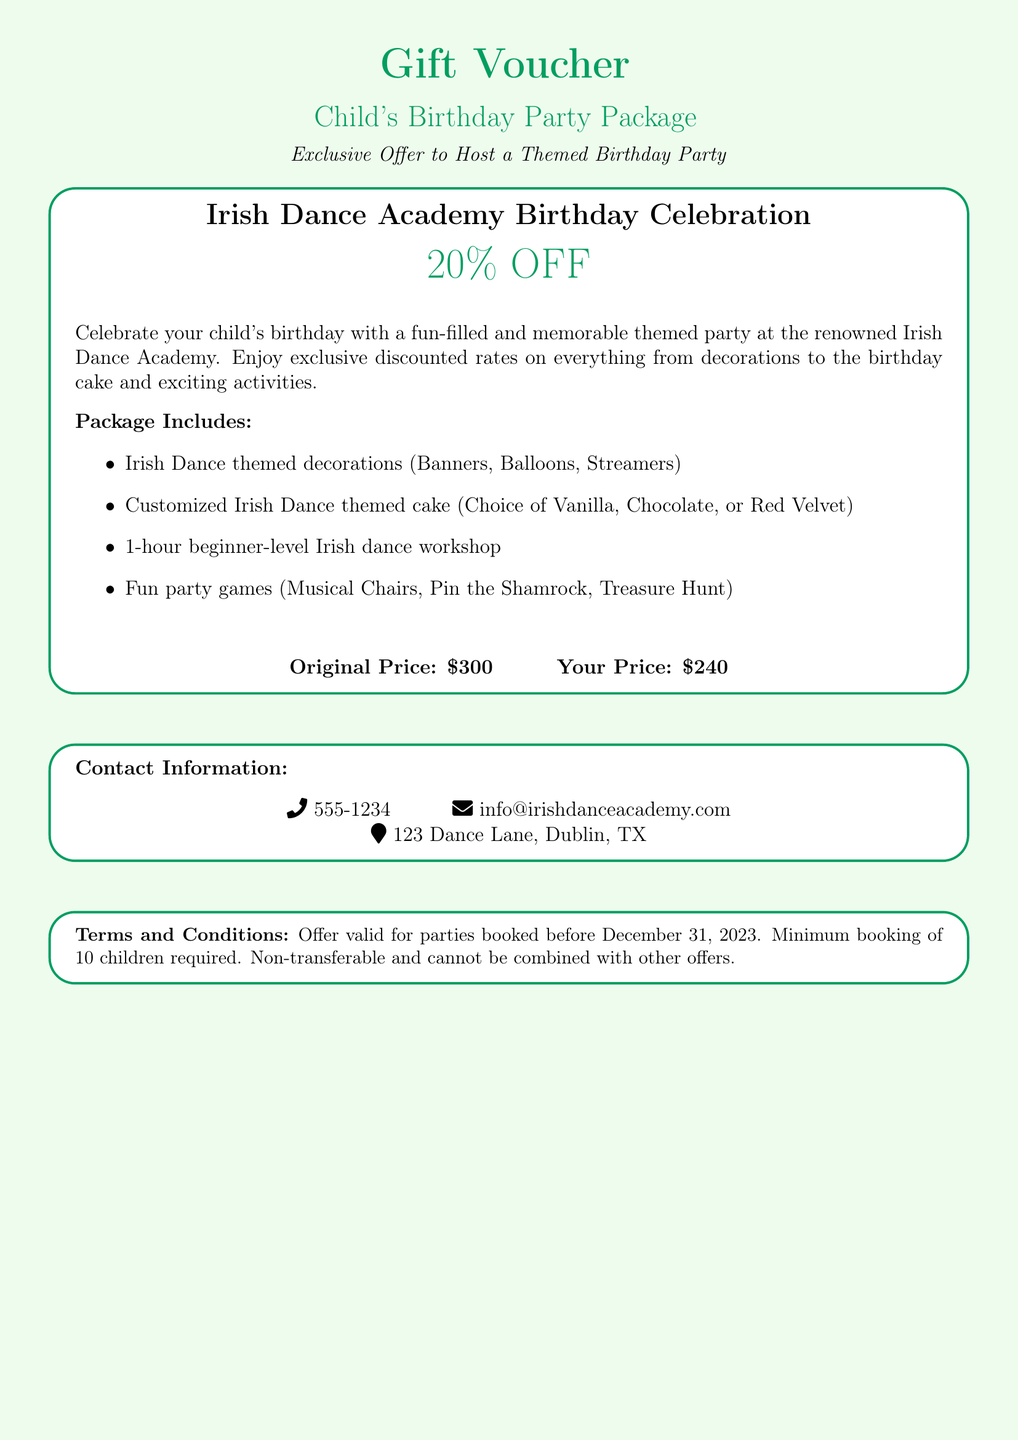what is the discount percentage for the birthday party package? The document states a discount of 20% off the original price for the birthday party package.
Answer: 20% OFF what is the original price of the birthday party package? The original price mentioned in the document for the birthday party package is $300.
Answer: $300 what is the discounted price of the birthday party package? The discounted price after the 20% off is clearly shown as $240 in the document.
Answer: $240 what activities are included in the package? The document lists several activities included in the package such as a beginner-level Irish dance workshop and fun party games like Musical Chairs.
Answer: 1-hour beginner-level Irish dance workshop, Fun party games what is the minimum number of children required for booking? The document specifies that a minimum booking of 10 children is required to avail of the package.
Answer: 10 children who can be contacted for more information? The document provides a phone number (555-1234) and an email (info@irishdanceacademy.com) for contact information.
Answer: 555-1234 where is the location of the venue? The venue address stated in the document is 123 Dance Lane, Dublin, TX.
Answer: 123 Dance Lane, Dublin, TX what is one theme featured in the birthday party package? The document indicates that the party theme is focused on Irish Dance, incorporating themed decorations and a cake.
Answer: Irish Dance 